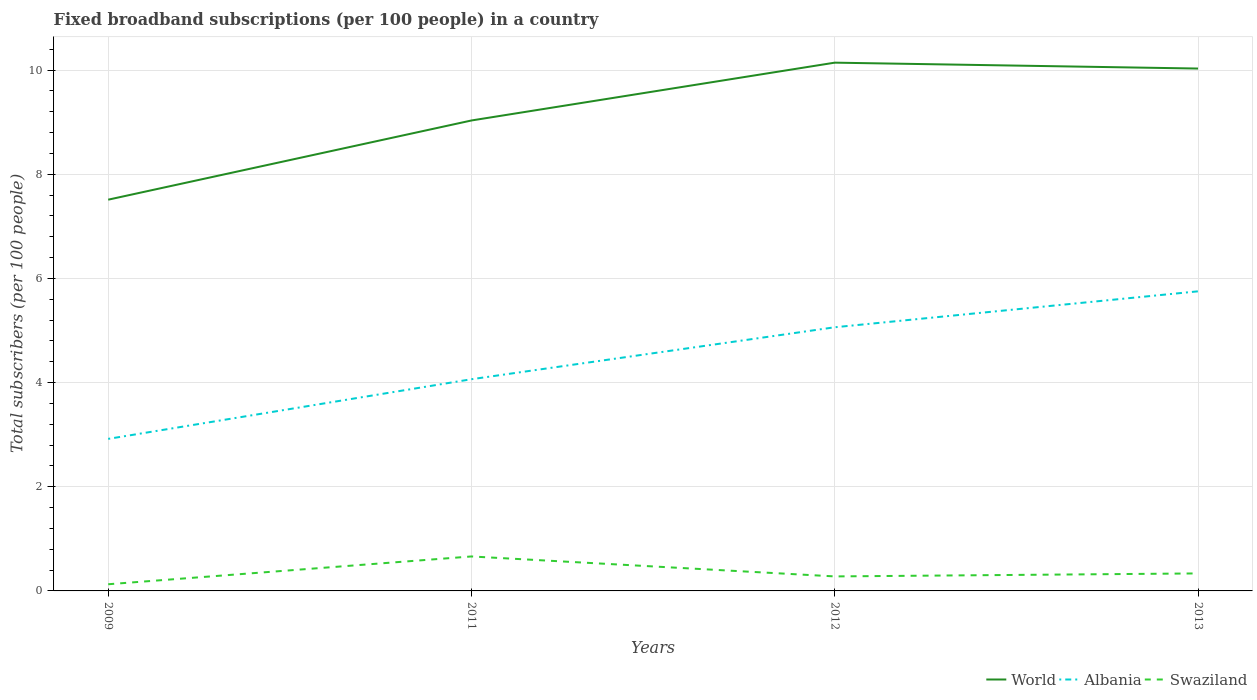How many different coloured lines are there?
Provide a succinct answer. 3. Does the line corresponding to Swaziland intersect with the line corresponding to Albania?
Offer a very short reply. No. Is the number of lines equal to the number of legend labels?
Make the answer very short. Yes. Across all years, what is the maximum number of broadband subscriptions in Albania?
Make the answer very short. 2.92. What is the total number of broadband subscriptions in Albania in the graph?
Make the answer very short. -2.83. What is the difference between the highest and the second highest number of broadband subscriptions in Albania?
Offer a terse response. 2.83. What is the difference between the highest and the lowest number of broadband subscriptions in Swaziland?
Give a very brief answer. 1. Are the values on the major ticks of Y-axis written in scientific E-notation?
Your answer should be compact. No. Does the graph contain any zero values?
Your response must be concise. No. Does the graph contain grids?
Keep it short and to the point. Yes. How many legend labels are there?
Keep it short and to the point. 3. What is the title of the graph?
Your answer should be very brief. Fixed broadband subscriptions (per 100 people) in a country. What is the label or title of the Y-axis?
Make the answer very short. Total subscribers (per 100 people). What is the Total subscribers (per 100 people) in World in 2009?
Keep it short and to the point. 7.51. What is the Total subscribers (per 100 people) in Albania in 2009?
Offer a terse response. 2.92. What is the Total subscribers (per 100 people) in Swaziland in 2009?
Give a very brief answer. 0.13. What is the Total subscribers (per 100 people) in World in 2011?
Your answer should be compact. 9.03. What is the Total subscribers (per 100 people) of Albania in 2011?
Give a very brief answer. 4.07. What is the Total subscribers (per 100 people) in Swaziland in 2011?
Your response must be concise. 0.66. What is the Total subscribers (per 100 people) in World in 2012?
Your response must be concise. 10.14. What is the Total subscribers (per 100 people) of Albania in 2012?
Give a very brief answer. 5.06. What is the Total subscribers (per 100 people) of Swaziland in 2012?
Your answer should be very brief. 0.28. What is the Total subscribers (per 100 people) of World in 2013?
Give a very brief answer. 10.03. What is the Total subscribers (per 100 people) of Albania in 2013?
Your answer should be very brief. 5.75. What is the Total subscribers (per 100 people) in Swaziland in 2013?
Make the answer very short. 0.34. Across all years, what is the maximum Total subscribers (per 100 people) of World?
Your response must be concise. 10.14. Across all years, what is the maximum Total subscribers (per 100 people) of Albania?
Provide a short and direct response. 5.75. Across all years, what is the maximum Total subscribers (per 100 people) in Swaziland?
Ensure brevity in your answer.  0.66. Across all years, what is the minimum Total subscribers (per 100 people) of World?
Keep it short and to the point. 7.51. Across all years, what is the minimum Total subscribers (per 100 people) of Albania?
Offer a very short reply. 2.92. Across all years, what is the minimum Total subscribers (per 100 people) of Swaziland?
Your response must be concise. 0.13. What is the total Total subscribers (per 100 people) in World in the graph?
Your answer should be very brief. 36.72. What is the total Total subscribers (per 100 people) of Albania in the graph?
Provide a short and direct response. 17.8. What is the total Total subscribers (per 100 people) in Swaziland in the graph?
Make the answer very short. 1.4. What is the difference between the Total subscribers (per 100 people) of World in 2009 and that in 2011?
Your response must be concise. -1.52. What is the difference between the Total subscribers (per 100 people) in Albania in 2009 and that in 2011?
Offer a terse response. -1.15. What is the difference between the Total subscribers (per 100 people) in Swaziland in 2009 and that in 2011?
Your answer should be compact. -0.53. What is the difference between the Total subscribers (per 100 people) in World in 2009 and that in 2012?
Provide a short and direct response. -2.63. What is the difference between the Total subscribers (per 100 people) in Albania in 2009 and that in 2012?
Your answer should be very brief. -2.14. What is the difference between the Total subscribers (per 100 people) of Swaziland in 2009 and that in 2012?
Make the answer very short. -0.15. What is the difference between the Total subscribers (per 100 people) in World in 2009 and that in 2013?
Offer a terse response. -2.52. What is the difference between the Total subscribers (per 100 people) in Albania in 2009 and that in 2013?
Your answer should be compact. -2.83. What is the difference between the Total subscribers (per 100 people) in Swaziland in 2009 and that in 2013?
Offer a very short reply. -0.21. What is the difference between the Total subscribers (per 100 people) in World in 2011 and that in 2012?
Your answer should be compact. -1.11. What is the difference between the Total subscribers (per 100 people) of Albania in 2011 and that in 2012?
Your response must be concise. -1. What is the difference between the Total subscribers (per 100 people) of Swaziland in 2011 and that in 2012?
Provide a short and direct response. 0.38. What is the difference between the Total subscribers (per 100 people) in World in 2011 and that in 2013?
Your response must be concise. -1. What is the difference between the Total subscribers (per 100 people) in Albania in 2011 and that in 2013?
Your response must be concise. -1.69. What is the difference between the Total subscribers (per 100 people) in Swaziland in 2011 and that in 2013?
Give a very brief answer. 0.33. What is the difference between the Total subscribers (per 100 people) of World in 2012 and that in 2013?
Your answer should be very brief. 0.11. What is the difference between the Total subscribers (per 100 people) of Albania in 2012 and that in 2013?
Your answer should be very brief. -0.69. What is the difference between the Total subscribers (per 100 people) of Swaziland in 2012 and that in 2013?
Keep it short and to the point. -0.06. What is the difference between the Total subscribers (per 100 people) of World in 2009 and the Total subscribers (per 100 people) of Albania in 2011?
Offer a very short reply. 3.45. What is the difference between the Total subscribers (per 100 people) in World in 2009 and the Total subscribers (per 100 people) in Swaziland in 2011?
Your answer should be very brief. 6.85. What is the difference between the Total subscribers (per 100 people) of Albania in 2009 and the Total subscribers (per 100 people) of Swaziland in 2011?
Your answer should be very brief. 2.26. What is the difference between the Total subscribers (per 100 people) in World in 2009 and the Total subscribers (per 100 people) in Albania in 2012?
Provide a short and direct response. 2.45. What is the difference between the Total subscribers (per 100 people) of World in 2009 and the Total subscribers (per 100 people) of Swaziland in 2012?
Provide a succinct answer. 7.23. What is the difference between the Total subscribers (per 100 people) in Albania in 2009 and the Total subscribers (per 100 people) in Swaziland in 2012?
Offer a very short reply. 2.64. What is the difference between the Total subscribers (per 100 people) of World in 2009 and the Total subscribers (per 100 people) of Albania in 2013?
Provide a short and direct response. 1.76. What is the difference between the Total subscribers (per 100 people) in World in 2009 and the Total subscribers (per 100 people) in Swaziland in 2013?
Give a very brief answer. 7.18. What is the difference between the Total subscribers (per 100 people) in Albania in 2009 and the Total subscribers (per 100 people) in Swaziland in 2013?
Your answer should be compact. 2.58. What is the difference between the Total subscribers (per 100 people) in World in 2011 and the Total subscribers (per 100 people) in Albania in 2012?
Your response must be concise. 3.97. What is the difference between the Total subscribers (per 100 people) of World in 2011 and the Total subscribers (per 100 people) of Swaziland in 2012?
Your response must be concise. 8.76. What is the difference between the Total subscribers (per 100 people) in Albania in 2011 and the Total subscribers (per 100 people) in Swaziland in 2012?
Provide a short and direct response. 3.79. What is the difference between the Total subscribers (per 100 people) of World in 2011 and the Total subscribers (per 100 people) of Albania in 2013?
Provide a succinct answer. 3.28. What is the difference between the Total subscribers (per 100 people) of World in 2011 and the Total subscribers (per 100 people) of Swaziland in 2013?
Keep it short and to the point. 8.7. What is the difference between the Total subscribers (per 100 people) in Albania in 2011 and the Total subscribers (per 100 people) in Swaziland in 2013?
Provide a succinct answer. 3.73. What is the difference between the Total subscribers (per 100 people) of World in 2012 and the Total subscribers (per 100 people) of Albania in 2013?
Your answer should be compact. 4.39. What is the difference between the Total subscribers (per 100 people) of World in 2012 and the Total subscribers (per 100 people) of Swaziland in 2013?
Offer a very short reply. 9.81. What is the difference between the Total subscribers (per 100 people) of Albania in 2012 and the Total subscribers (per 100 people) of Swaziland in 2013?
Make the answer very short. 4.73. What is the average Total subscribers (per 100 people) in World per year?
Offer a very short reply. 9.18. What is the average Total subscribers (per 100 people) in Albania per year?
Give a very brief answer. 4.45. What is the average Total subscribers (per 100 people) in Swaziland per year?
Keep it short and to the point. 0.35. In the year 2009, what is the difference between the Total subscribers (per 100 people) of World and Total subscribers (per 100 people) of Albania?
Keep it short and to the point. 4.59. In the year 2009, what is the difference between the Total subscribers (per 100 people) of World and Total subscribers (per 100 people) of Swaziland?
Offer a very short reply. 7.38. In the year 2009, what is the difference between the Total subscribers (per 100 people) of Albania and Total subscribers (per 100 people) of Swaziland?
Provide a short and direct response. 2.79. In the year 2011, what is the difference between the Total subscribers (per 100 people) in World and Total subscribers (per 100 people) in Albania?
Your answer should be compact. 4.97. In the year 2011, what is the difference between the Total subscribers (per 100 people) in World and Total subscribers (per 100 people) in Swaziland?
Give a very brief answer. 8.37. In the year 2011, what is the difference between the Total subscribers (per 100 people) of Albania and Total subscribers (per 100 people) of Swaziland?
Your answer should be compact. 3.4. In the year 2012, what is the difference between the Total subscribers (per 100 people) of World and Total subscribers (per 100 people) of Albania?
Keep it short and to the point. 5.08. In the year 2012, what is the difference between the Total subscribers (per 100 people) in World and Total subscribers (per 100 people) in Swaziland?
Your answer should be compact. 9.87. In the year 2012, what is the difference between the Total subscribers (per 100 people) in Albania and Total subscribers (per 100 people) in Swaziland?
Keep it short and to the point. 4.78. In the year 2013, what is the difference between the Total subscribers (per 100 people) of World and Total subscribers (per 100 people) of Albania?
Your answer should be compact. 4.28. In the year 2013, what is the difference between the Total subscribers (per 100 people) of World and Total subscribers (per 100 people) of Swaziland?
Your answer should be compact. 9.69. In the year 2013, what is the difference between the Total subscribers (per 100 people) of Albania and Total subscribers (per 100 people) of Swaziland?
Make the answer very short. 5.42. What is the ratio of the Total subscribers (per 100 people) in World in 2009 to that in 2011?
Ensure brevity in your answer.  0.83. What is the ratio of the Total subscribers (per 100 people) in Albania in 2009 to that in 2011?
Keep it short and to the point. 0.72. What is the ratio of the Total subscribers (per 100 people) of Swaziland in 2009 to that in 2011?
Provide a short and direct response. 0.19. What is the ratio of the Total subscribers (per 100 people) in World in 2009 to that in 2012?
Your answer should be compact. 0.74. What is the ratio of the Total subscribers (per 100 people) of Albania in 2009 to that in 2012?
Provide a succinct answer. 0.58. What is the ratio of the Total subscribers (per 100 people) of Swaziland in 2009 to that in 2012?
Keep it short and to the point. 0.46. What is the ratio of the Total subscribers (per 100 people) of World in 2009 to that in 2013?
Your answer should be compact. 0.75. What is the ratio of the Total subscribers (per 100 people) of Albania in 2009 to that in 2013?
Provide a short and direct response. 0.51. What is the ratio of the Total subscribers (per 100 people) of Swaziland in 2009 to that in 2013?
Keep it short and to the point. 0.38. What is the ratio of the Total subscribers (per 100 people) in World in 2011 to that in 2012?
Your answer should be compact. 0.89. What is the ratio of the Total subscribers (per 100 people) in Albania in 2011 to that in 2012?
Offer a terse response. 0.8. What is the ratio of the Total subscribers (per 100 people) in Swaziland in 2011 to that in 2012?
Your response must be concise. 2.38. What is the ratio of the Total subscribers (per 100 people) in World in 2011 to that in 2013?
Provide a short and direct response. 0.9. What is the ratio of the Total subscribers (per 100 people) of Albania in 2011 to that in 2013?
Offer a terse response. 0.71. What is the ratio of the Total subscribers (per 100 people) of Swaziland in 2011 to that in 2013?
Your response must be concise. 1.97. What is the ratio of the Total subscribers (per 100 people) in World in 2012 to that in 2013?
Offer a very short reply. 1.01. What is the ratio of the Total subscribers (per 100 people) of Albania in 2012 to that in 2013?
Provide a short and direct response. 0.88. What is the ratio of the Total subscribers (per 100 people) in Swaziland in 2012 to that in 2013?
Your response must be concise. 0.83. What is the difference between the highest and the second highest Total subscribers (per 100 people) of World?
Your answer should be very brief. 0.11. What is the difference between the highest and the second highest Total subscribers (per 100 people) in Albania?
Your answer should be compact. 0.69. What is the difference between the highest and the second highest Total subscribers (per 100 people) of Swaziland?
Provide a succinct answer. 0.33. What is the difference between the highest and the lowest Total subscribers (per 100 people) of World?
Your response must be concise. 2.63. What is the difference between the highest and the lowest Total subscribers (per 100 people) in Albania?
Your response must be concise. 2.83. What is the difference between the highest and the lowest Total subscribers (per 100 people) in Swaziland?
Give a very brief answer. 0.53. 